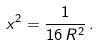Convert formula to latex. <formula><loc_0><loc_0><loc_500><loc_500>x ^ { 2 } = \frac { 1 } { 1 6 \, R ^ { 2 } } \, .</formula> 